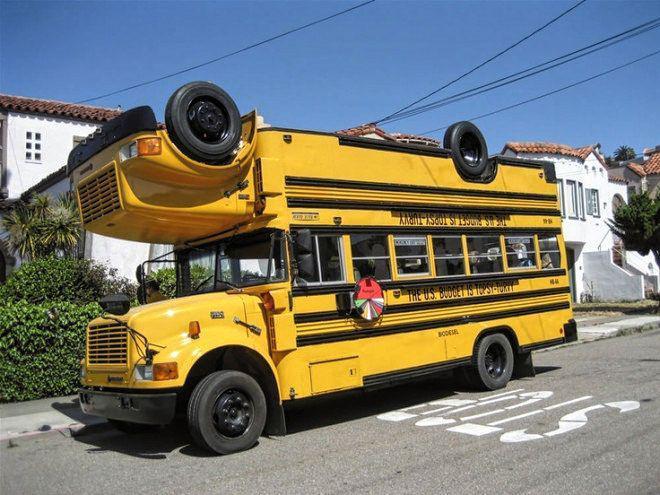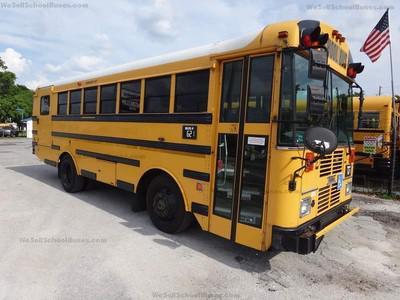The first image is the image on the left, the second image is the image on the right. For the images displayed, is the sentence "The buses on the left and right face opposite directions, and one has a flat front while the other has a hood that projects forward." factually correct? Answer yes or no. No. 